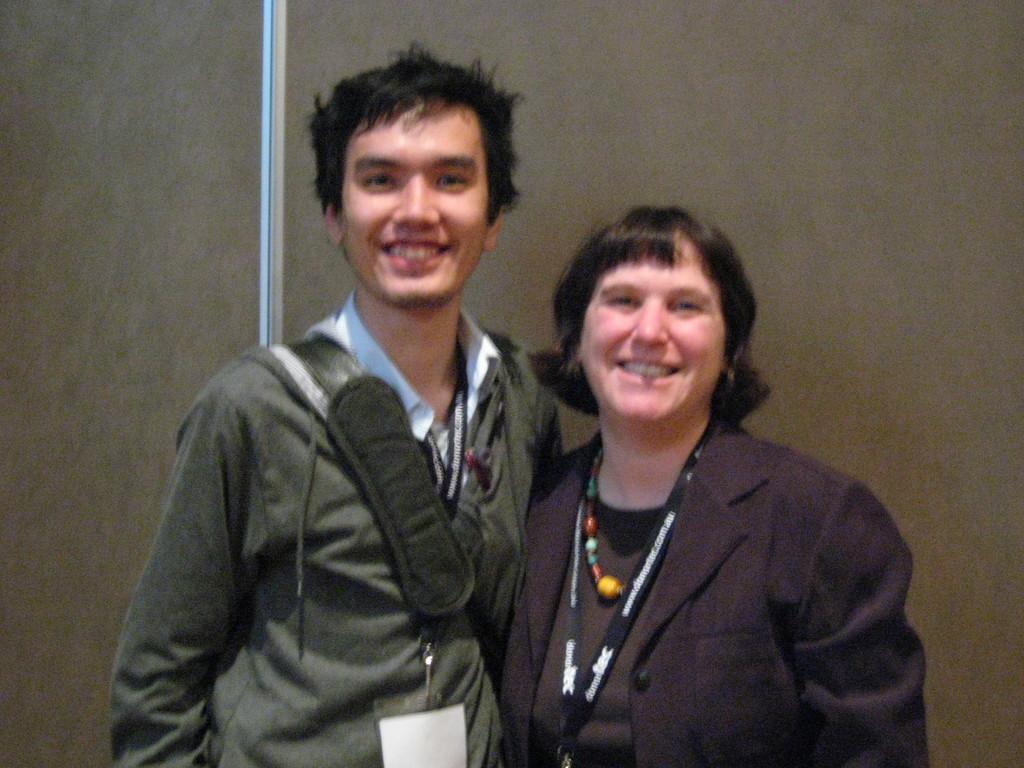How would you summarize this image in a sentence or two? In the foreground of the picture there is a man and a woman standing, behind them it is wall. 